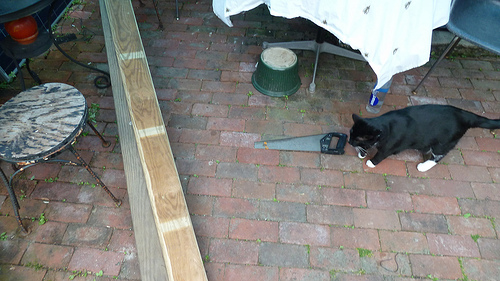<image>
Is the cat on the brick? Yes. Looking at the image, I can see the cat is positioned on top of the brick, with the brick providing support. Is the saw behind the cat? No. The saw is not behind the cat. From this viewpoint, the saw appears to be positioned elsewhere in the scene. 